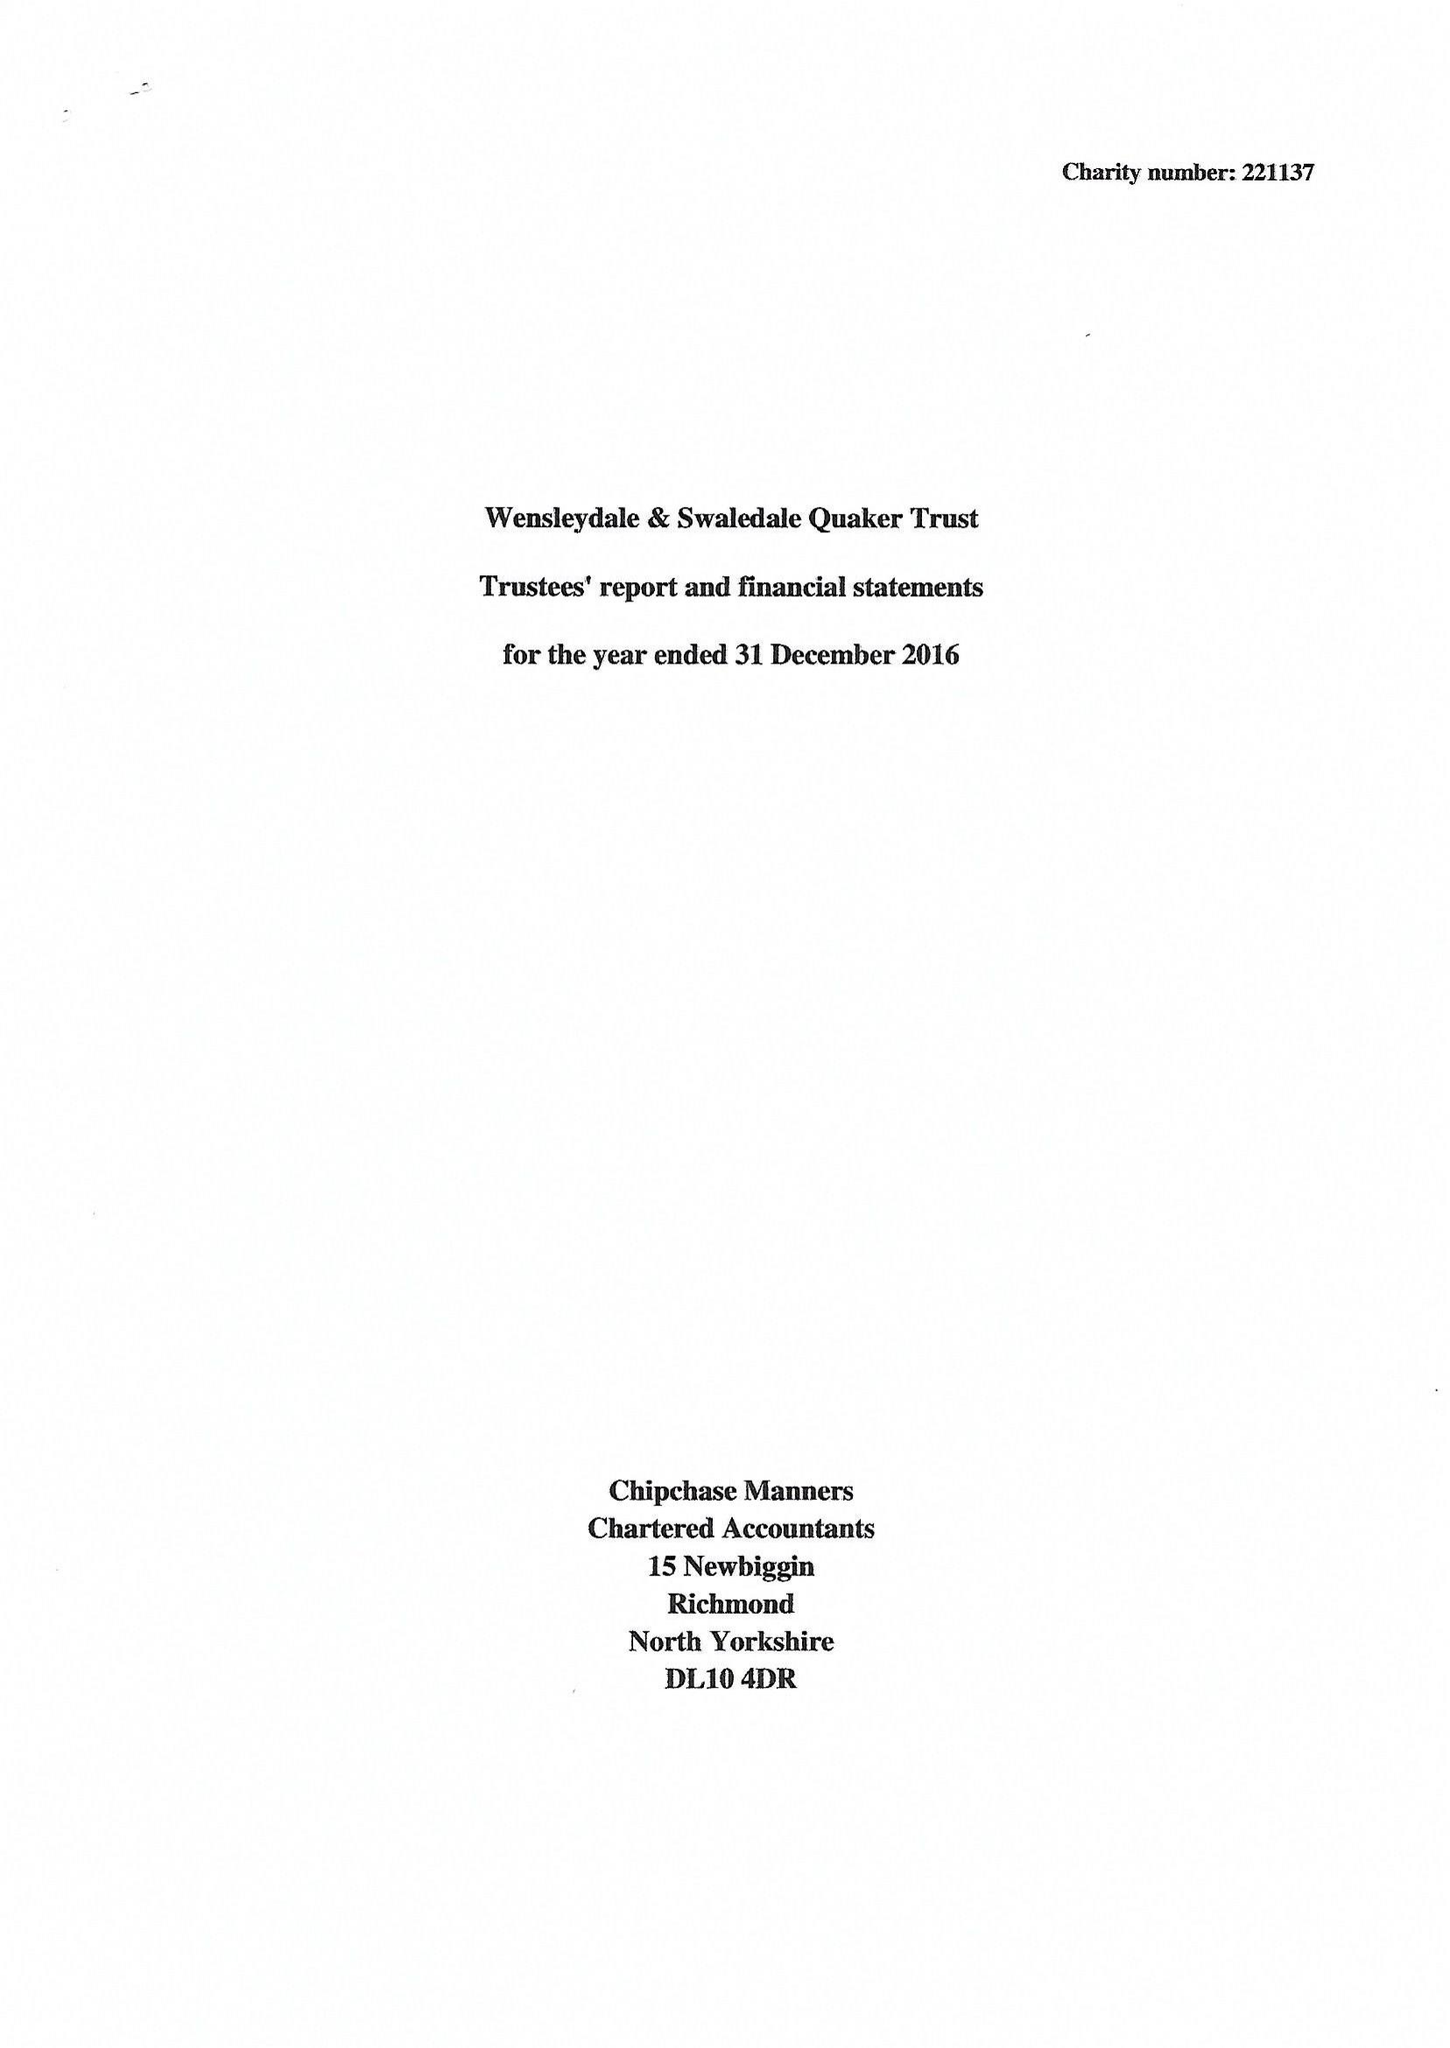What is the value for the report_date?
Answer the question using a single word or phrase. 2016-12-31 